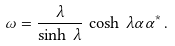<formula> <loc_0><loc_0><loc_500><loc_500>\omega = \frac { \lambda } { \sinh \, \lambda } \, \cosh \, \lambda \alpha \alpha ^ { * } \, .</formula> 